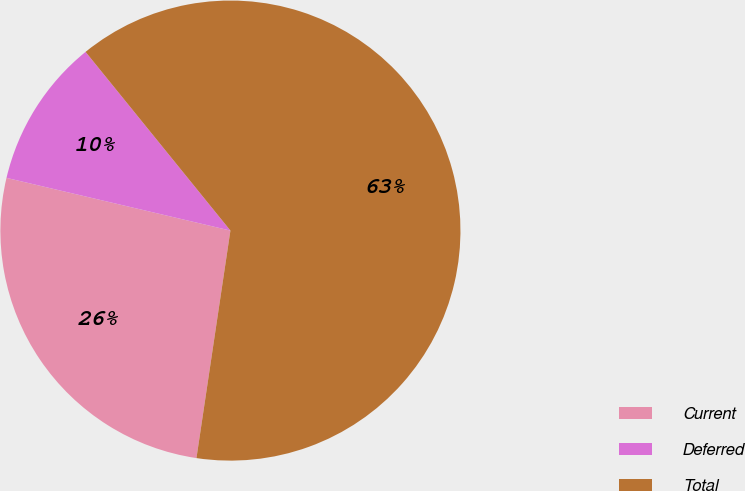Convert chart. <chart><loc_0><loc_0><loc_500><loc_500><pie_chart><fcel>Current<fcel>Deferred<fcel>Total<nl><fcel>26.32%<fcel>10.48%<fcel>63.2%<nl></chart> 